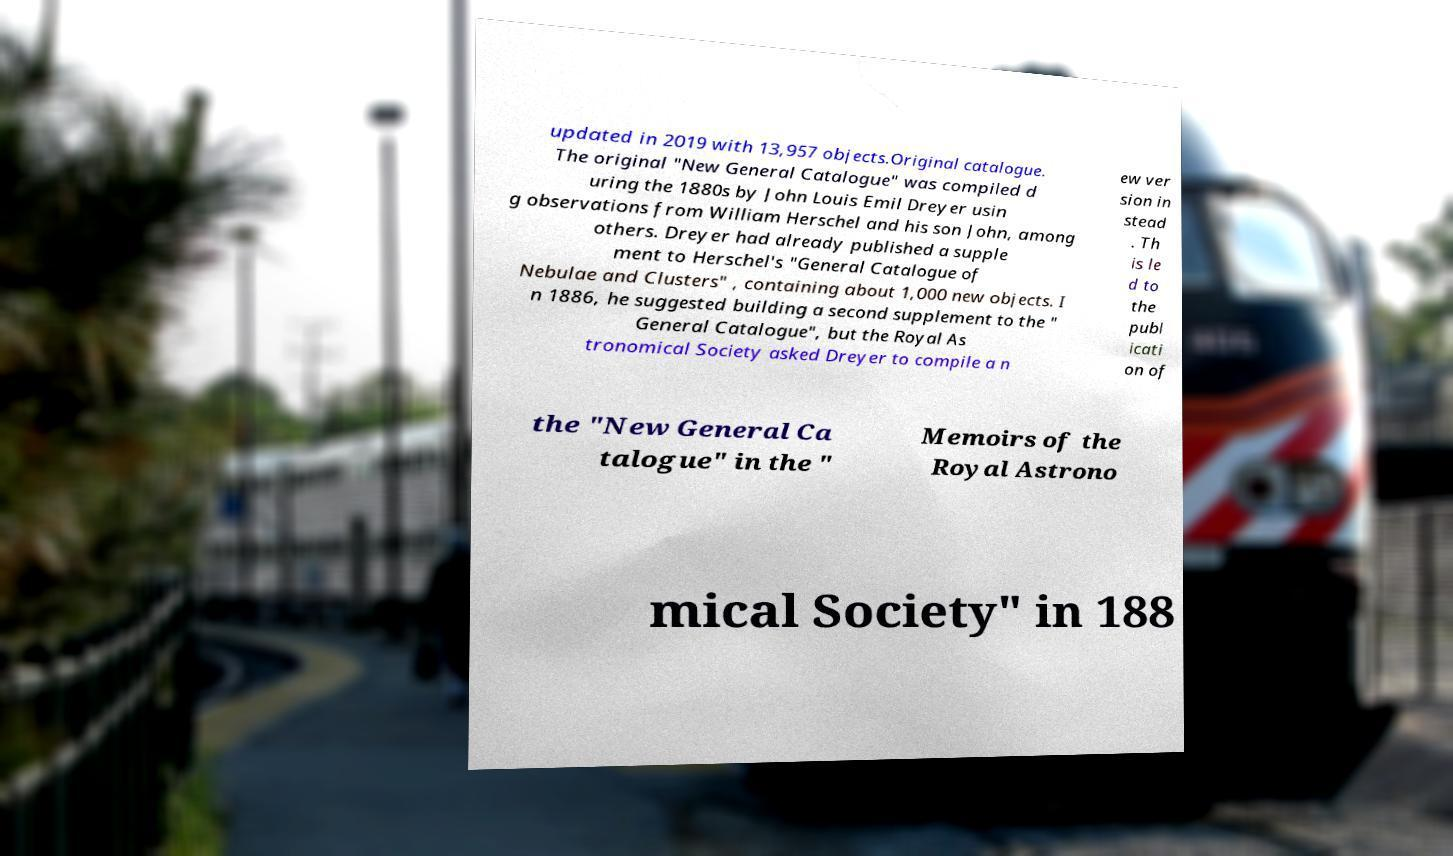Please read and relay the text visible in this image. What does it say? updated in 2019 with 13,957 objects.Original catalogue. The original "New General Catalogue" was compiled d uring the 1880s by John Louis Emil Dreyer usin g observations from William Herschel and his son John, among others. Dreyer had already published a supple ment to Herschel's "General Catalogue of Nebulae and Clusters" , containing about 1,000 new objects. I n 1886, he suggested building a second supplement to the " General Catalogue", but the Royal As tronomical Society asked Dreyer to compile a n ew ver sion in stead . Th is le d to the publ icati on of the "New General Ca talogue" in the " Memoirs of the Royal Astrono mical Society" in 188 